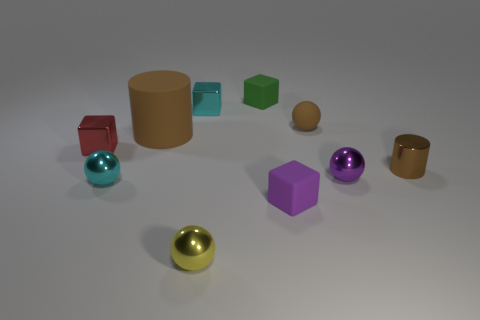Is there any other thing that has the same size as the brown matte cylinder?
Your response must be concise. No. Is the number of big brown matte cylinders behind the big brown matte cylinder less than the number of tiny cubes that are behind the brown rubber sphere?
Make the answer very short. Yes. What is the shape of the small purple object right of the tiny rubber cube that is in front of the cyan shiny thing behind the small brown cylinder?
Ensure brevity in your answer.  Sphere. There is a metallic object that is behind the purple ball and in front of the tiny red thing; what shape is it?
Your answer should be compact. Cylinder. Are there any large brown cubes that have the same material as the tiny red thing?
Your answer should be very brief. No. What is the size of the other cylinder that is the same color as the small cylinder?
Your response must be concise. Large. What is the color of the cube that is in front of the brown shiny cylinder?
Make the answer very short. Purple. There is a yellow object; is it the same shape as the brown rubber thing left of the tiny purple block?
Give a very brief answer. No. Is there a tiny rubber sphere of the same color as the small cylinder?
Your answer should be compact. Yes. There is a cylinder that is the same material as the green thing; what is its size?
Make the answer very short. Large. 